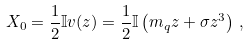<formula> <loc_0><loc_0><loc_500><loc_500>X _ { 0 } = \frac { 1 } { 2 } \mathbb { I } v ( z ) = \frac { 1 } { 2 } \mathbb { I } \left ( m _ { q } z + \sigma z ^ { 3 } \right ) \, ,</formula> 